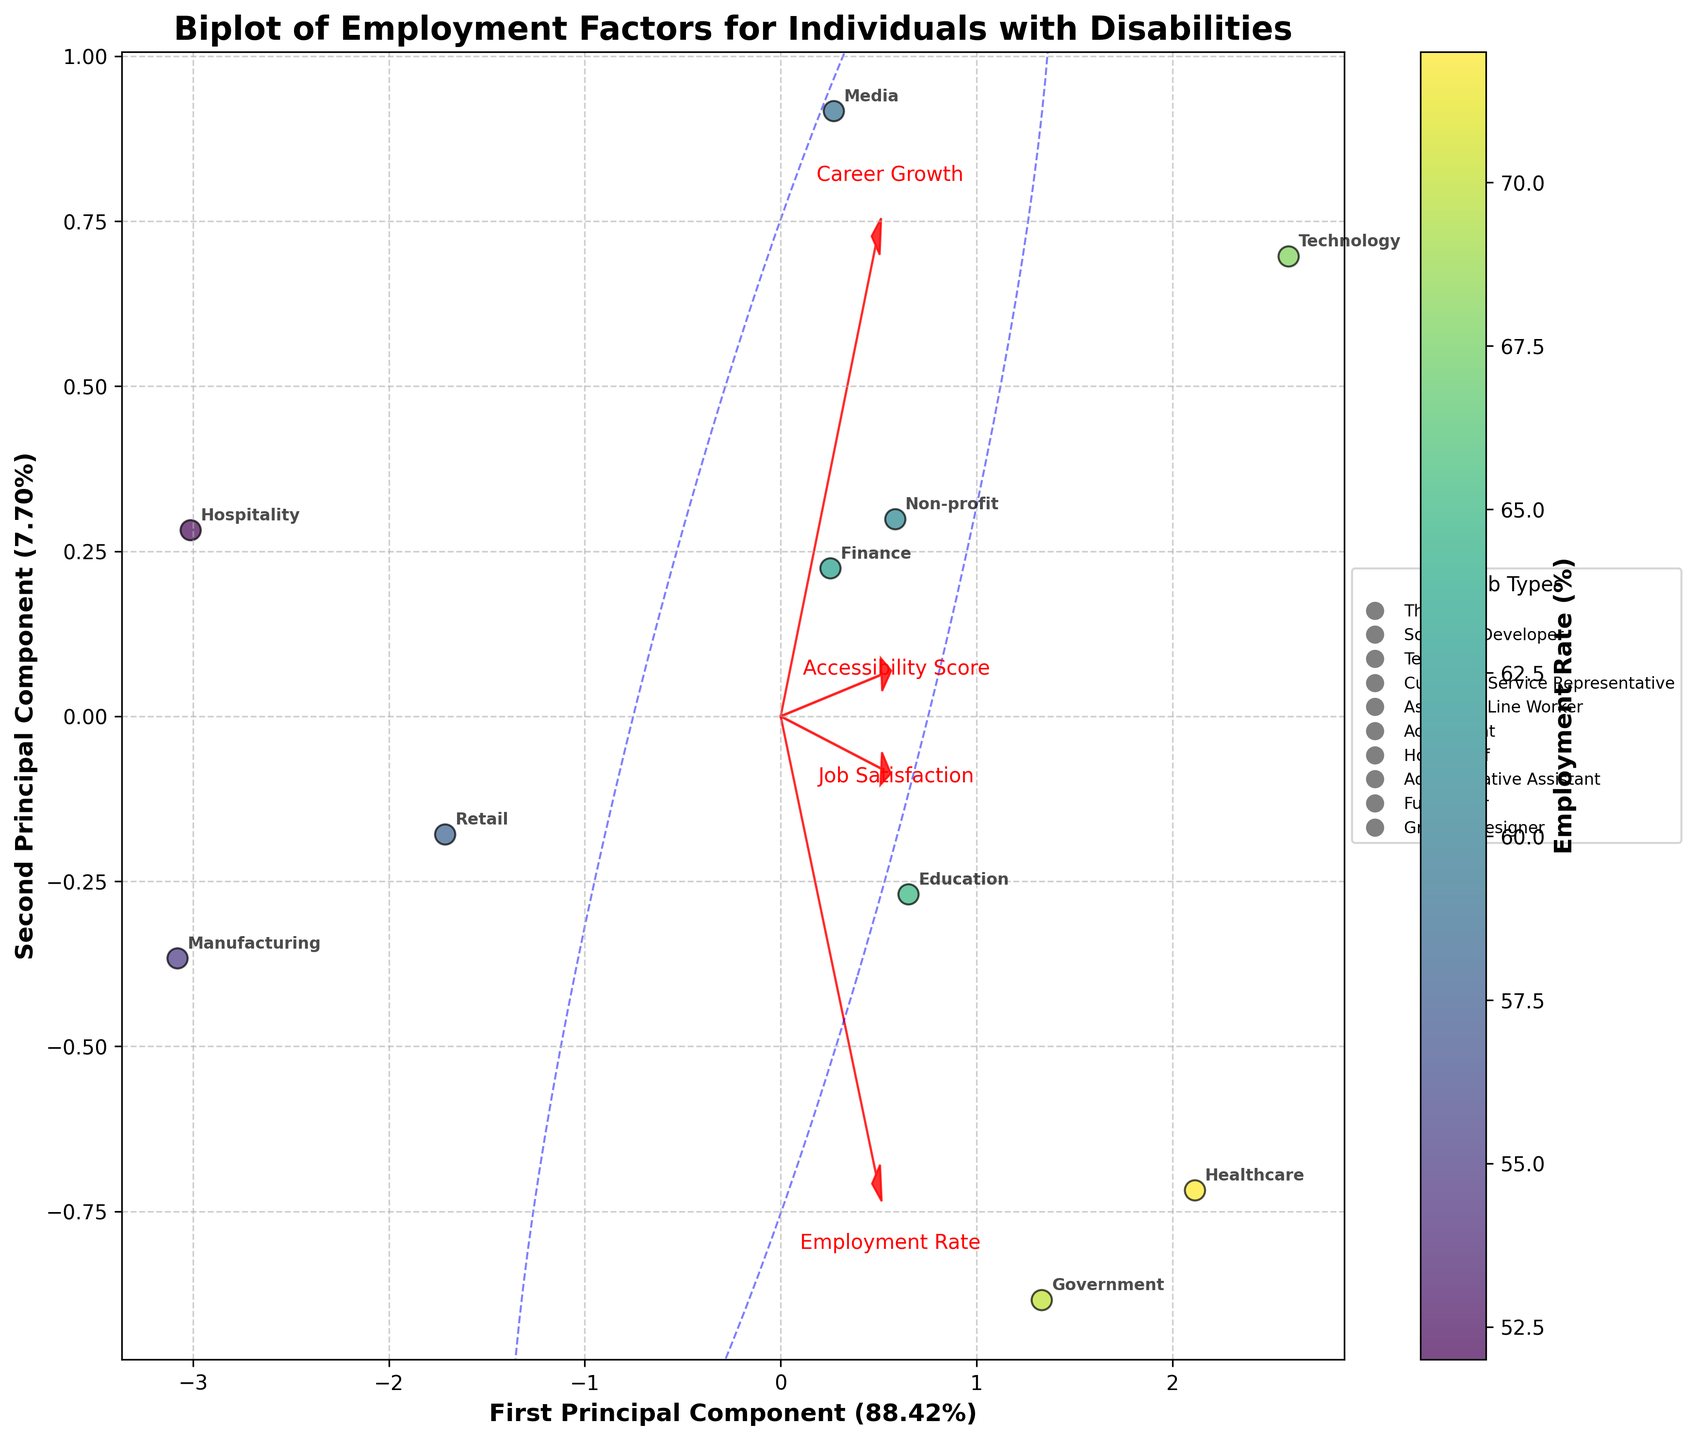How many data points are there in the figure? The figure displays each industry as a single data point. By counting them, we see there are 10 different industries listed in the data provided.
Answer: 10 Which industry has the highest employment rate for individuals with disabilities? By examining the color gradient of the scatter points representing employment rate, we see that the Healthcare industry is the one with the highest employment rate, as indicated by its position in the yellow end of the color spectrum.
Answer: Healthcare Which feature vector points most sharply to the right on the biplot? By observing the feature vectors, we can see that 'Accessibility Score' points most sharply to the right, given its direction on the plot.
Answer: Accessibility Score Between the 'Teacher' and 'Software Developer' job types, which has higher job satisfaction? By locating their respective industries, Education and Technology, and comparing their placement on the Job Satisfaction axis, we can see that Technology (Software Developer) has slightly higher satisfaction.
Answer: Software Developer Is there a clear separation between job types in the biplot? By looking at the scatter of data points, there is no distinct clustering by job types that separates one set of jobs from another clearly, suggesting a mixture of job types across the plot.
Answer: No What fraction of the total variance is explained by the first principal component? Looking at the axis labels, the first principal component explains 47% of the total variance.
Answer: 47% Comparing Healthcare and Manufacturing, which is closer to the direction of the 'Career Growth' vector? By noting the placement relative to the 'Career Growth' vector, it's evident that Healthcare is much closer to this vector than Manufacturing.
Answer: Healthcare What is the relationship between the 'Accessibility Score' and the biplot's first principal component? Observing the direction of the 'Accessibility Score' vector, it aligns closely with the first principal component axis, indicating that 'Accessibility Score' significantly contributes to the variance captured by this component.
Answer: Significant positive relationship Which two industries have nearly equal employment rates but differ in job satisfaction? Comparing points with similar colors (employment rates), Retail and Media have nearly equal employment rates but differ in their placement along the job satisfaction dimension, with Media showing higher satisfaction.
Answer: Retail and Media What is the direction of 'Job Satisfaction' relative to the second principal component? By examining the direction of the 'Job Satisfaction' vector, it aligns closely with the second principal component axis, suggesting that 'Job Satisfaction' substantially contributes to the variance captured by this component.
Answer: Aligned with second component 